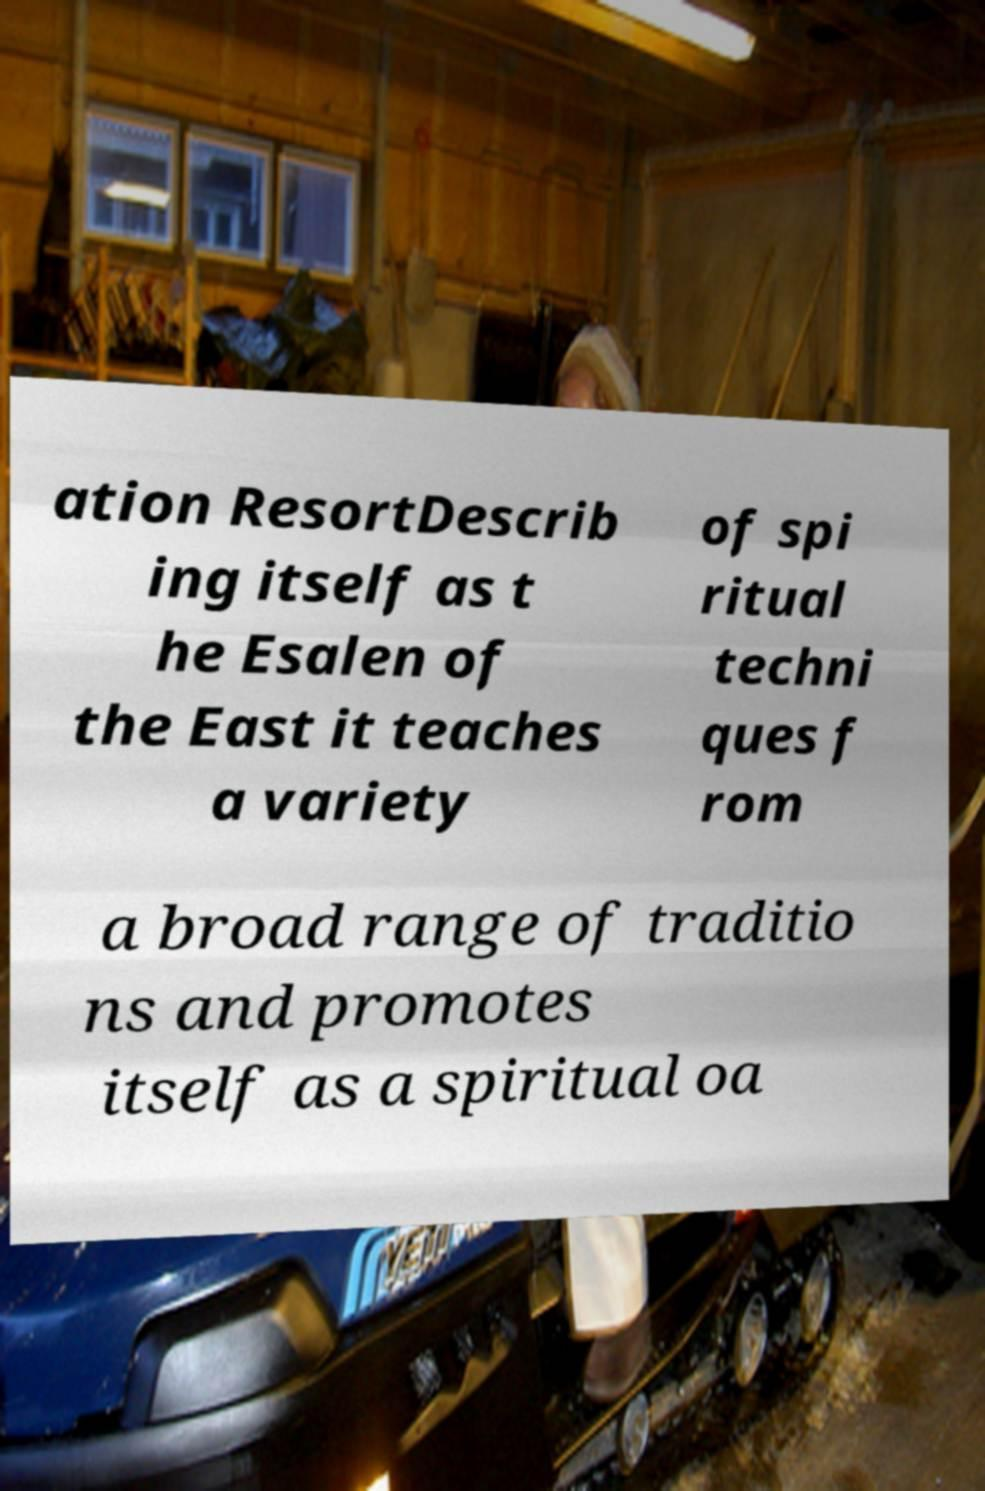Can you accurately transcribe the text from the provided image for me? ation ResortDescrib ing itself as t he Esalen of the East it teaches a variety of spi ritual techni ques f rom a broad range of traditio ns and promotes itself as a spiritual oa 